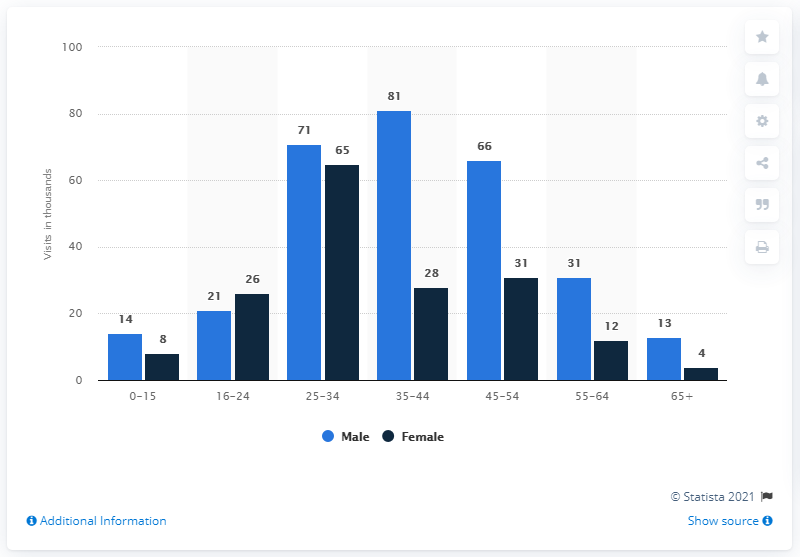Highlight a few significant elements in this photo. The age group that visited the London Olympic Games the most was 25-34 year olds. According to the data, the age group with the smallest difference between the number of male and female visitors is 16-24 year olds. 